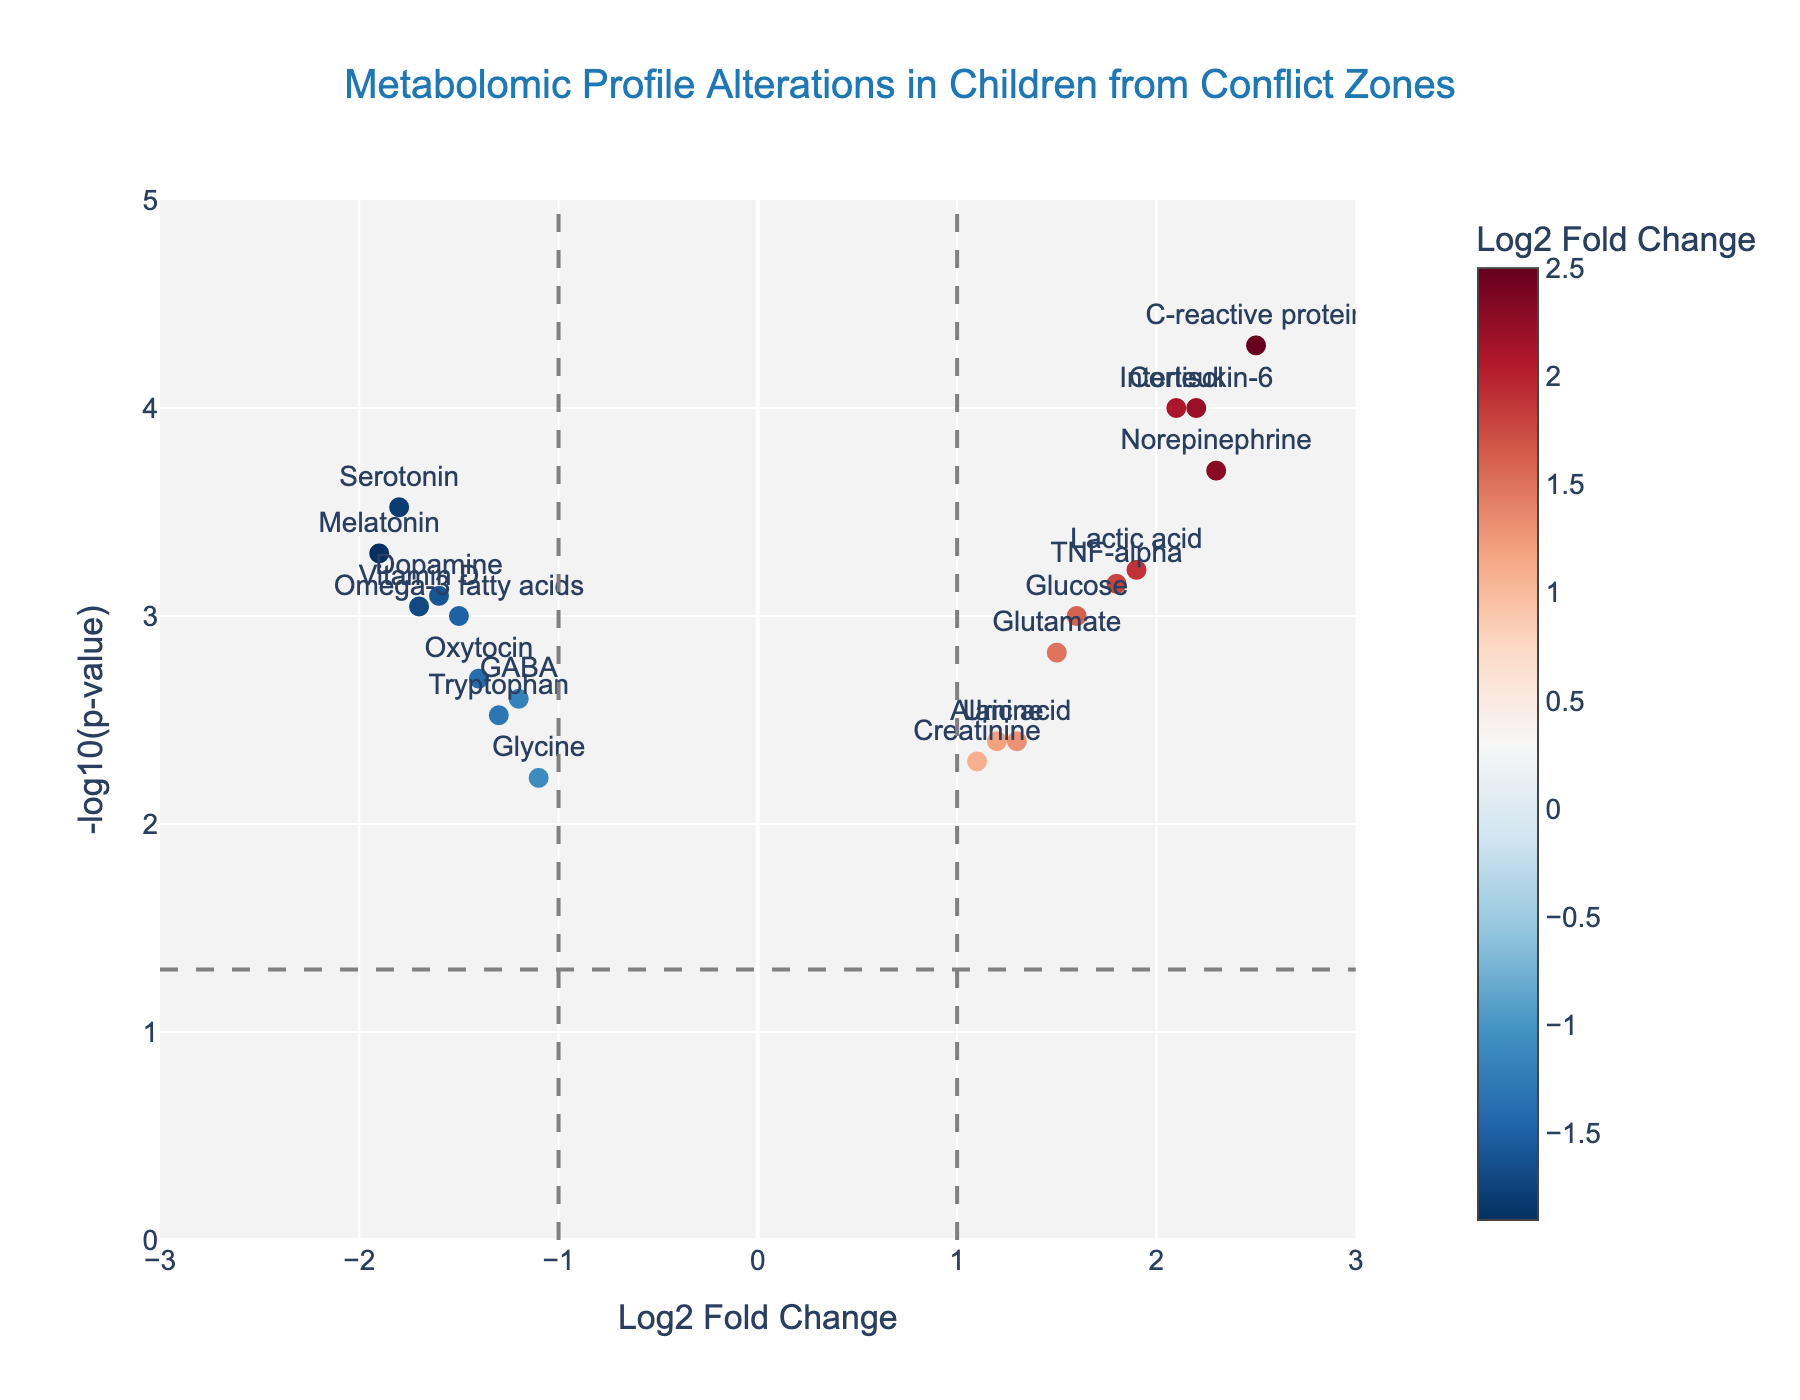What is the title of the plot? The title of the plot is typically presented at the top of the figure. It reads "Metabolomic Profile Alterations in Children from Conflict Zones".
Answer: Metabolomic Profile Alterations in Children from Conflict Zones What do the x-axis and y-axis represent respectively? The x-axis represents the Log2 Fold Change, which indicates the magnitude of change in metabolite levels, while the y-axis represents the -log10(p-value), which indicates the statistical significance of those changes.
Answer: Log2 Fold Change and -log10(p-value) How many metabolites have a Log2 Fold Change greater than 2? To determine this, count the number of data points (metabolites) that are positioned beyond Log2 Fold Change of 2 on the x-axis.
Answer: 3 Which metabolite has the lowest p-value and what is its corresponding metabolite? The lowest p-value will correspond to the highest -log10(p-value) on the y-axis. The metabolite with this highest value can be identified.
Answer: C-reactive protein Which metabolites have both a negative Log2 Fold Change and a p-value less than 0.05? Look for metabolites that lie to the left of the x-axis (negative Log2 Fold Change) and lie above the horizontal line representing -log10(0.05).
Answer: Serotonin, GABA, Dopamine, Melatonin, Oxytocin, Vitamin D, Omega-3 fatty acids, Tryptophan, Glycine What is the Log2 Fold Change of Serotonin? Identify the data point associated with Serotonin and read its x-axis value.
Answer: -1.8 Compare the Log2 Fold Change values of Cortisol and Dopamine. Which one is higher? By comparing the positions of Cortisol and Dopamine on the x-axis, we see that Cortisol is further to the right than Dopamine.
Answer: Cortisol What do the vertical and horizontal dashed lines indicate on the plot? The vertical dashed lines at x = -1 and x = 1 represent thresholds for significant fold changes, while the horizontal dashed line at y ≈ 1.3 represents the p-value significance threshold of 0.05 converted to -log10(p-value).
Answer: Thresholds for significance in fold changes and p-value Name two metabolites that fall within the range -1 ≤ Log2 Fold Change ≤ 1 and have a p-value ≥ 0.05. Identify data points within the specified range on the x-axis and below the threshold line for p-value significance.
Answer: Creatinine, Alanine 